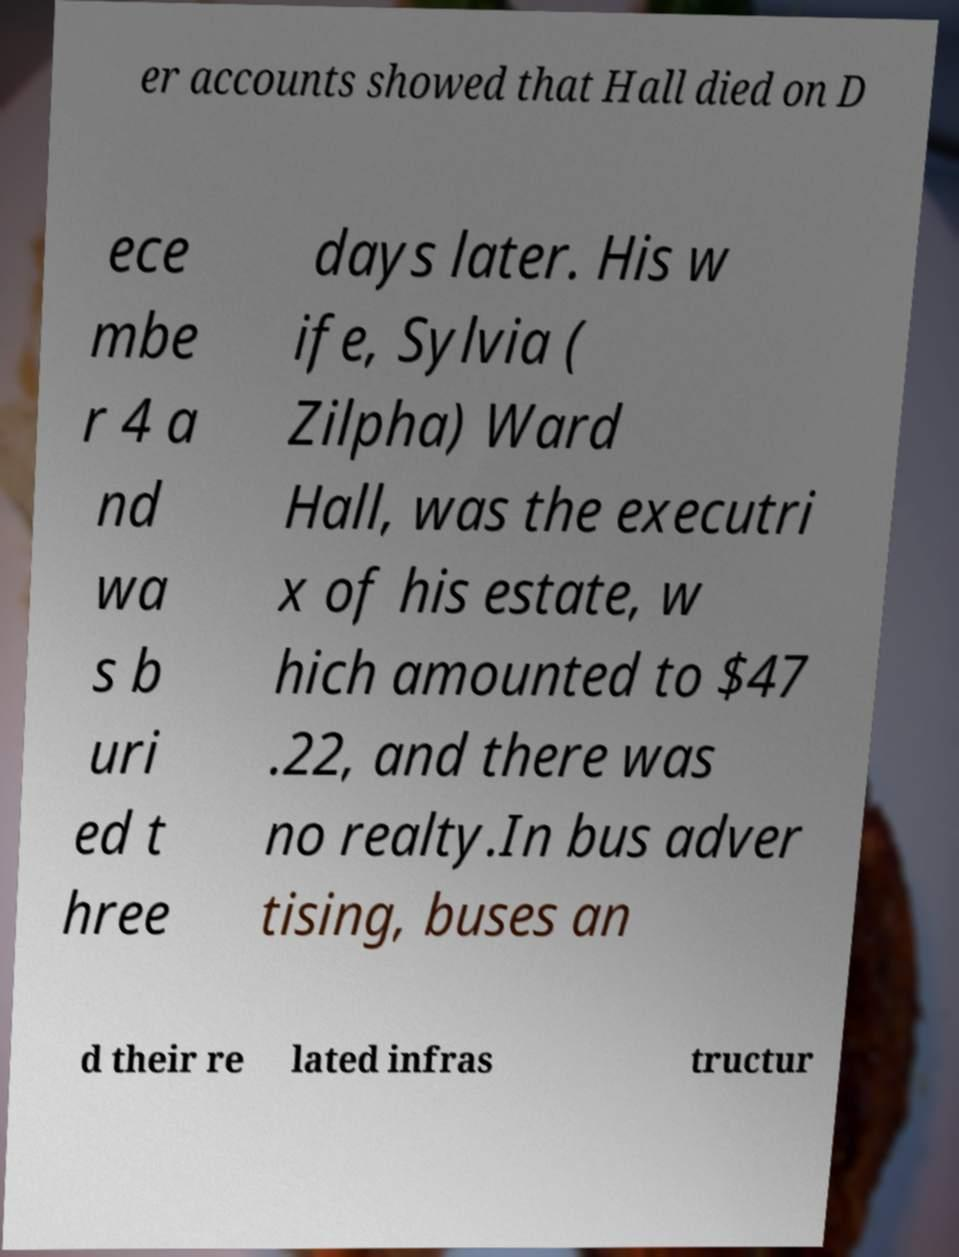Can you read and provide the text displayed in the image?This photo seems to have some interesting text. Can you extract and type it out for me? er accounts showed that Hall died on D ece mbe r 4 a nd wa s b uri ed t hree days later. His w ife, Sylvia ( Zilpha) Ward Hall, was the executri x of his estate, w hich amounted to $47 .22, and there was no realty.In bus adver tising, buses an d their re lated infras tructur 